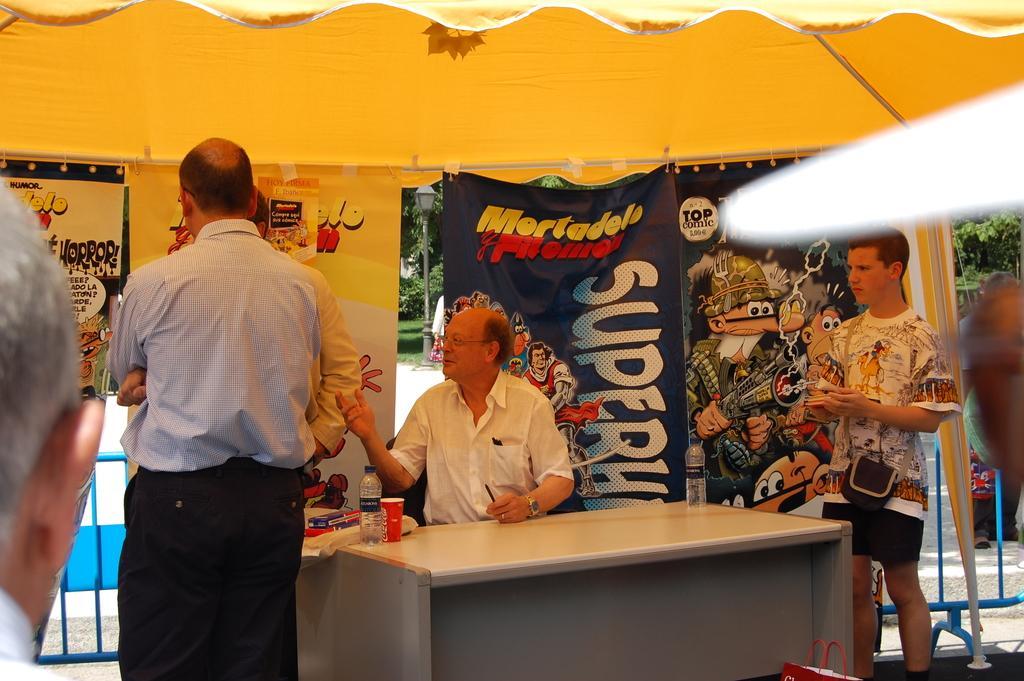Describe this image in one or two sentences. This image is clicked under the tent. There are four people in this image. In the background, there is a tent in yellow color and there are banners to the tent. In the front, there is a table behind which a man is sitting and wearing white shirt. On the table, there are bottle and glass. 